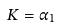Convert formula to latex. <formula><loc_0><loc_0><loc_500><loc_500>K = \alpha _ { 1 }</formula> 